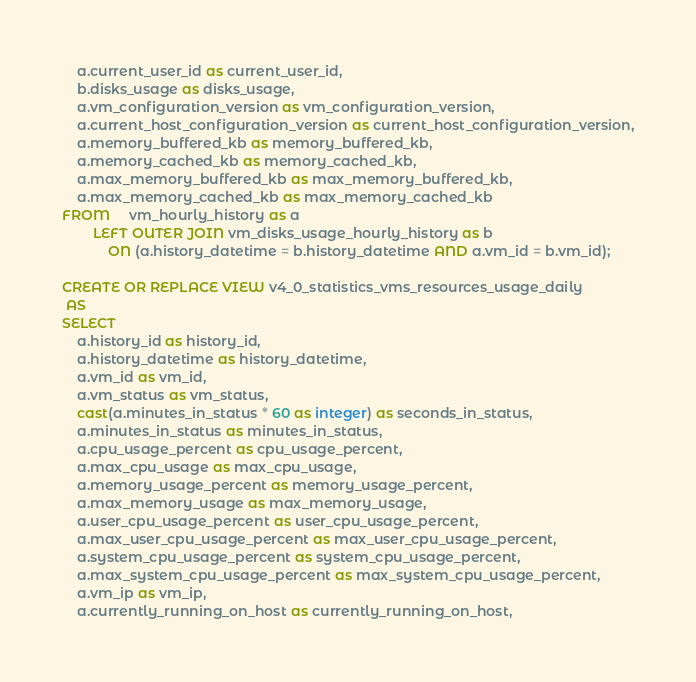<code> <loc_0><loc_0><loc_500><loc_500><_SQL_>    a.current_user_id as current_user_id,
    b.disks_usage as disks_usage,
    a.vm_configuration_version as vm_configuration_version,
    a.current_host_configuration_version as current_host_configuration_version,
    a.memory_buffered_kb as memory_buffered_kb,
    a.memory_cached_kb as memory_cached_kb,
    a.max_memory_buffered_kb as max_memory_buffered_kb,
    a.max_memory_cached_kb as max_memory_cached_kb
FROM     vm_hourly_history as a
        LEFT OUTER JOIN vm_disks_usage_hourly_history as b
            ON (a.history_datetime = b.history_datetime AND a.vm_id = b.vm_id);

CREATE OR REPLACE VIEW v4_0_statistics_vms_resources_usage_daily
 AS
SELECT
    a.history_id as history_id,
    a.history_datetime as history_datetime,
    a.vm_id as vm_id,
    a.vm_status as vm_status,
    cast(a.minutes_in_status * 60 as integer) as seconds_in_status,
    a.minutes_in_status as minutes_in_status,
    a.cpu_usage_percent as cpu_usage_percent,
    a.max_cpu_usage as max_cpu_usage,
    a.memory_usage_percent as memory_usage_percent,
    a.max_memory_usage as max_memory_usage,
    a.user_cpu_usage_percent as user_cpu_usage_percent,
    a.max_user_cpu_usage_percent as max_user_cpu_usage_percent,
    a.system_cpu_usage_percent as system_cpu_usage_percent,
    a.max_system_cpu_usage_percent as max_system_cpu_usage_percent,
    a.vm_ip as vm_ip,
    a.currently_running_on_host as currently_running_on_host,</code> 